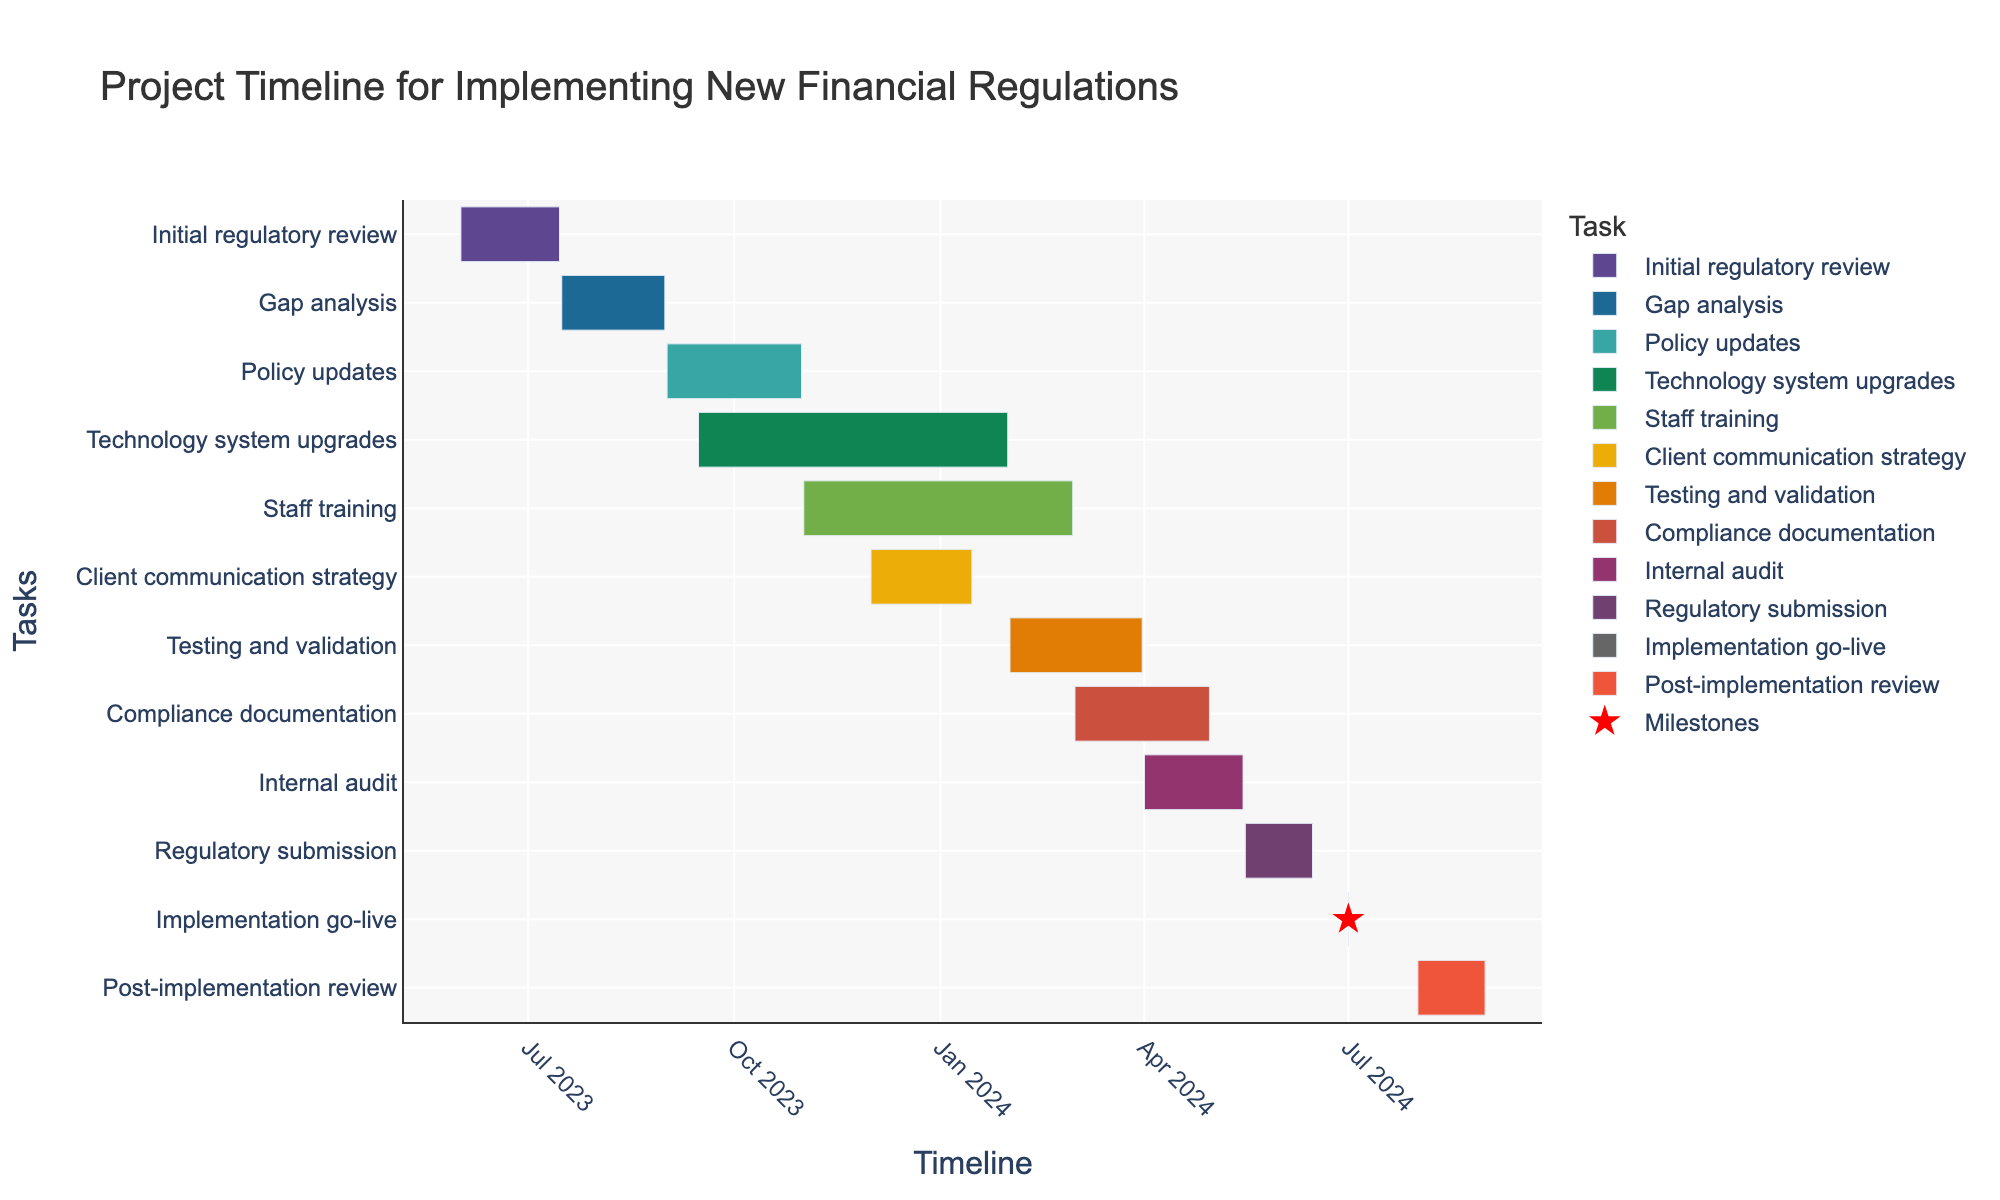What is the title of the Gantt chart? The title is usually displayed prominently at the top of the chart. For this Gantt chart, it says "Project Timeline for Implementing New Financial Regulations".
Answer: Project Timeline for Implementing New Financial Regulations How long is the "Initial regulatory review" task set to take? To find the duration, check the start and end dates of the "Initial regulatory review" task. The task starts on 2023-06-01 and ends on 2023-07-15. Calculating the difference, it spans 45 days.
Answer: 45 days Which task starts immediately after "Initial regulatory review"? Look for the start dates of tasks and compare them. "Gap analysis" starts on 2023-07-16, which is the day after "Initial regulatory review" ends on 2023-07-15.
Answer: Gap analysis What are the tasks running during September 2023? Review the start and end dates to see which tasks overlap with September 2023. Both "Policy updates" (2023-09-01 to 2023-10-31) and "Technology system upgrades" (2023-09-15 to 2024-01-31) run during this period.
Answer: Policy updates and Technology system upgrades Which task has the shortest duration? Identify tasks with a single-day duration. "Implementation go-live" occurs only on 2024-07-01, making it the shortest task.
Answer: Implementation go-live How many tasks have overlapping timelines in November 2023? Check the tasks happening in November 2023: "Policy updates" (till 2023-10-31 overlaps slightly), "Technology system upgrades" (2023-09-15 to 2024-01-31), and "Staff training" (2023-11-01 to 2024-02-29). There are three.
Answer: 3 tasks Which two tasks overlap the most in terms of their duration? Compare the overlapping periods of tasks. Both "Technology system upgrades" (2023-09-15 to 2024-01-31) and "Staff training" (2023-11-01 to 2024-02-29) overlap significantly from 2023-11-01 to 2024-01-31.
Answer: Technology system upgrades and Staff training What is the difference in duration between "Client communication strategy" and "Compliance documentation"? Calculate the duration of each task: "Client communication strategy" (2023-12-01 to 2024-01-15) is 1.5 months long, and "Compliance documentation" (2024-03-01 to 2024-04-30) is 2 months long. The difference is half a month.
Answer: 0.5 months Which task marks the final milestone? Identify tasks listed as milestones (single-day tasks). "Post-implementation review" ends on 2024-08-31, marking the last milestone.
Answer: Post-implementation review Given the project starts on 2023-06-01, how long in total is the project timeline until the last milestone? Start from the first task "Initial regulatory review" on 2023-06-01 and end at "Post-implementation review" on 2024-08-31. Calculate the total duration which is 456 days.
Answer: 456 days 